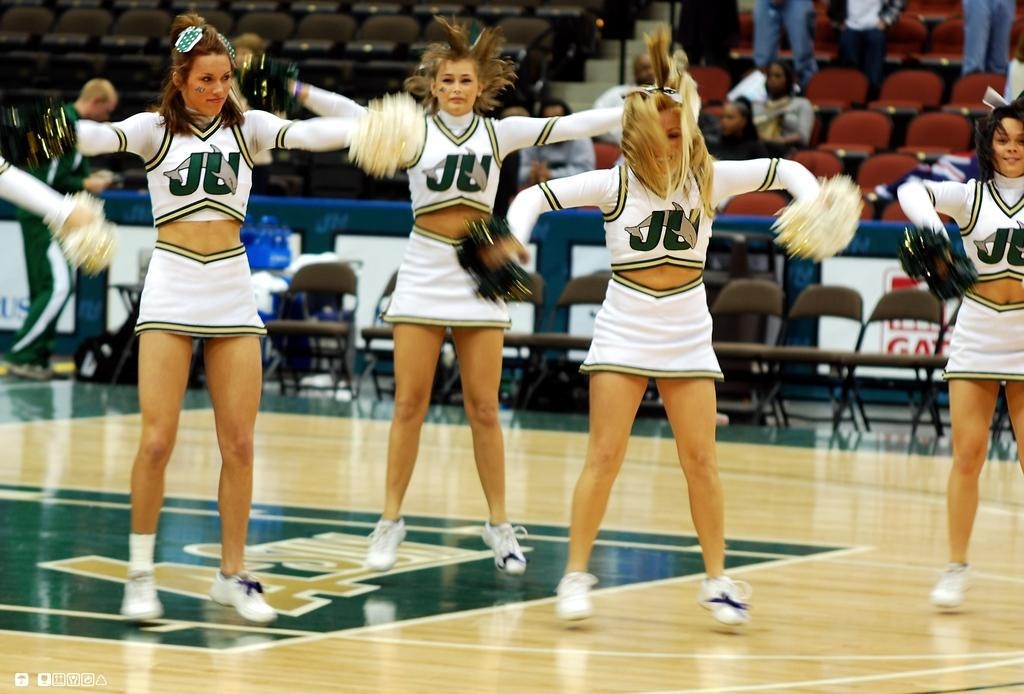<image>
Relay a brief, clear account of the picture shown. Cheerleaders are performing on a basketball court wearing the letters JU. 